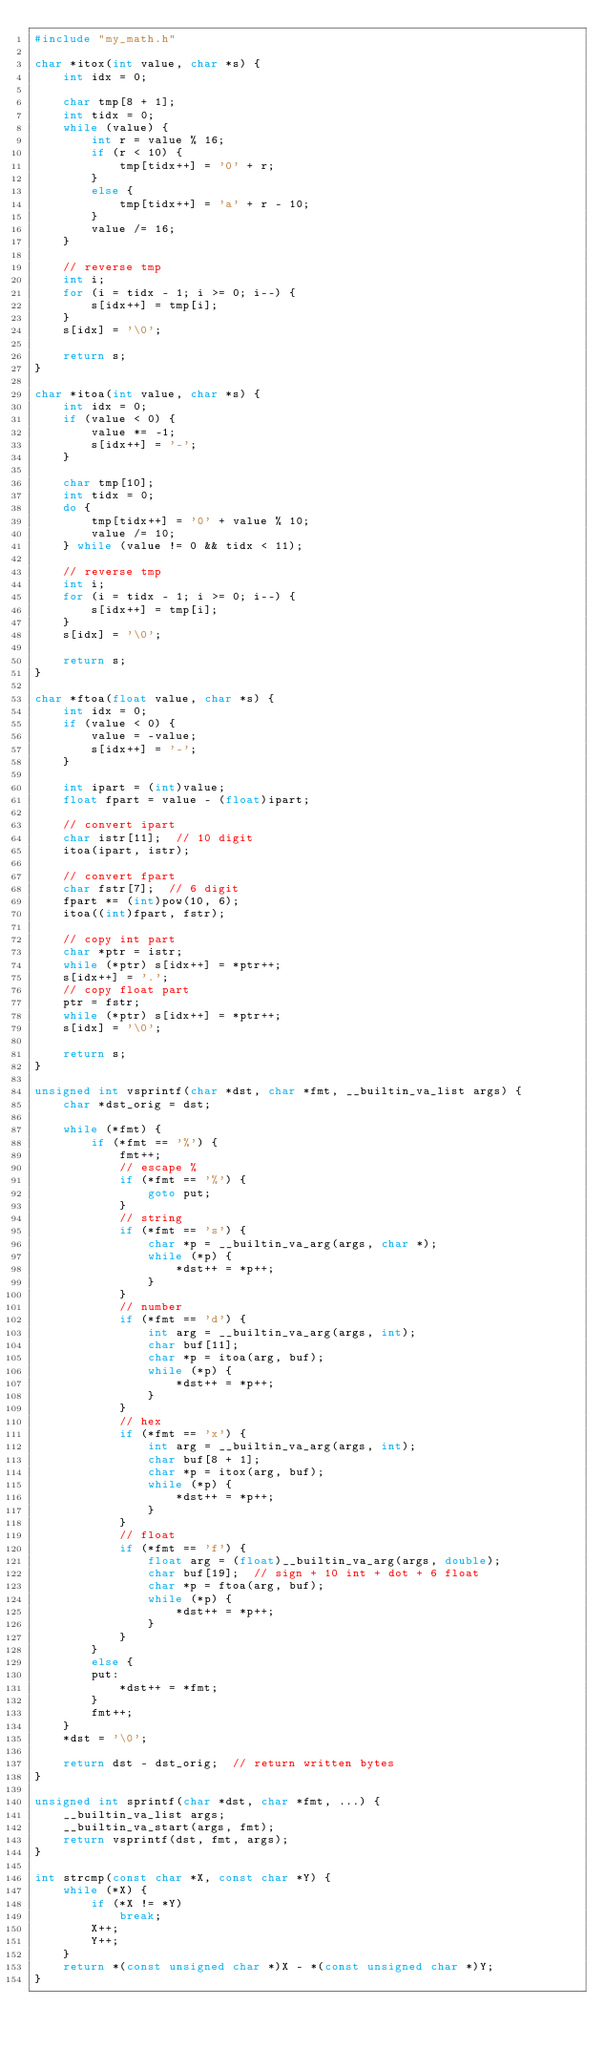Convert code to text. <code><loc_0><loc_0><loc_500><loc_500><_C_>#include "my_math.h"

char *itox(int value, char *s) {
    int idx = 0;

    char tmp[8 + 1];
    int tidx = 0;
    while (value) {
        int r = value % 16;
        if (r < 10) {
            tmp[tidx++] = '0' + r;
        }
        else {
            tmp[tidx++] = 'a' + r - 10;
        }
        value /= 16;
    }

    // reverse tmp
    int i;
    for (i = tidx - 1; i >= 0; i--) {
        s[idx++] = tmp[i];
    }
    s[idx] = '\0';

    return s;
}

char *itoa(int value, char *s) {
    int idx = 0;
    if (value < 0) {
        value *= -1;
        s[idx++] = '-';
    }

    char tmp[10];
    int tidx = 0;
    do {
        tmp[tidx++] = '0' + value % 10;
        value /= 10;
    } while (value != 0 && tidx < 11);

    // reverse tmp
    int i;
    for (i = tidx - 1; i >= 0; i--) {
        s[idx++] = tmp[i];
    }
    s[idx] = '\0';

    return s;
}

char *ftoa(float value, char *s) {
    int idx = 0;
    if (value < 0) {
        value = -value;
        s[idx++] = '-';
    }

    int ipart = (int)value;
    float fpart = value - (float)ipart;

    // convert ipart
    char istr[11];  // 10 digit
    itoa(ipart, istr);

    // convert fpart
    char fstr[7];  // 6 digit
    fpart *= (int)pow(10, 6);
    itoa((int)fpart, fstr);

    // copy int part
    char *ptr = istr;
    while (*ptr) s[idx++] = *ptr++;
    s[idx++] = '.';
    // copy float part
    ptr = fstr;
    while (*ptr) s[idx++] = *ptr++;
    s[idx] = '\0';

    return s;
}

unsigned int vsprintf(char *dst, char *fmt, __builtin_va_list args) {
    char *dst_orig = dst;

    while (*fmt) {
        if (*fmt == '%') {
            fmt++;
            // escape %
            if (*fmt == '%') {
                goto put;
            }
            // string
            if (*fmt == 's') {
                char *p = __builtin_va_arg(args, char *);
                while (*p) {
                    *dst++ = *p++;
                }
            }
            // number
            if (*fmt == 'd') {
                int arg = __builtin_va_arg(args, int);
                char buf[11];
                char *p = itoa(arg, buf);
                while (*p) {
                    *dst++ = *p++;
                }
            }
            // hex
            if (*fmt == 'x') {
                int arg = __builtin_va_arg(args, int);
                char buf[8 + 1];
                char *p = itox(arg, buf);
                while (*p) {
                    *dst++ = *p++;
                }
            }
            // float
            if (*fmt == 'f') {
                float arg = (float)__builtin_va_arg(args, double);
                char buf[19];  // sign + 10 int + dot + 6 float
                char *p = ftoa(arg, buf);
                while (*p) {
                    *dst++ = *p++;
                }
            }
        }
        else {
        put:
            *dst++ = *fmt;
        }
        fmt++;
    }
    *dst = '\0';

    return dst - dst_orig;  // return written bytes
}

unsigned int sprintf(char *dst, char *fmt, ...) {
    __builtin_va_list args;
    __builtin_va_start(args, fmt);
    return vsprintf(dst, fmt, args);
}

int strcmp(const char *X, const char *Y) {
    while (*X) {
        if (*X != *Y)
            break;
        X++;
        Y++;
    }
    return *(const unsigned char *)X - *(const unsigned char *)Y;
}</code> 